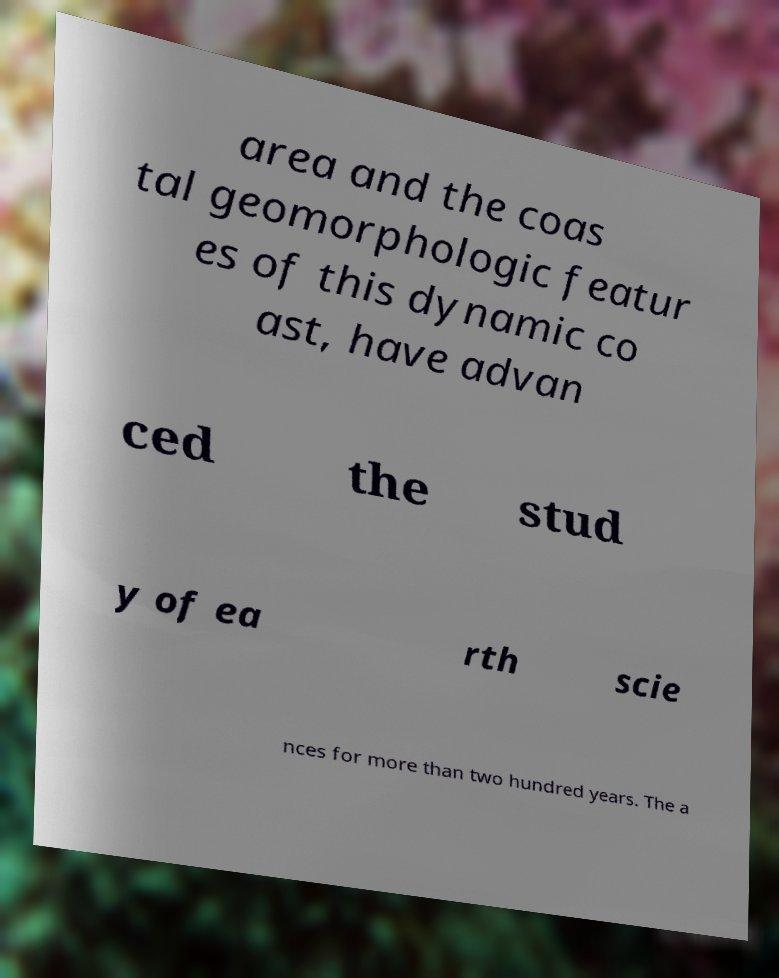Please read and relay the text visible in this image. What does it say? area and the coas tal geomorphologic featur es of this dynamic co ast, have advan ced the stud y of ea rth scie nces for more than two hundred years. The a 